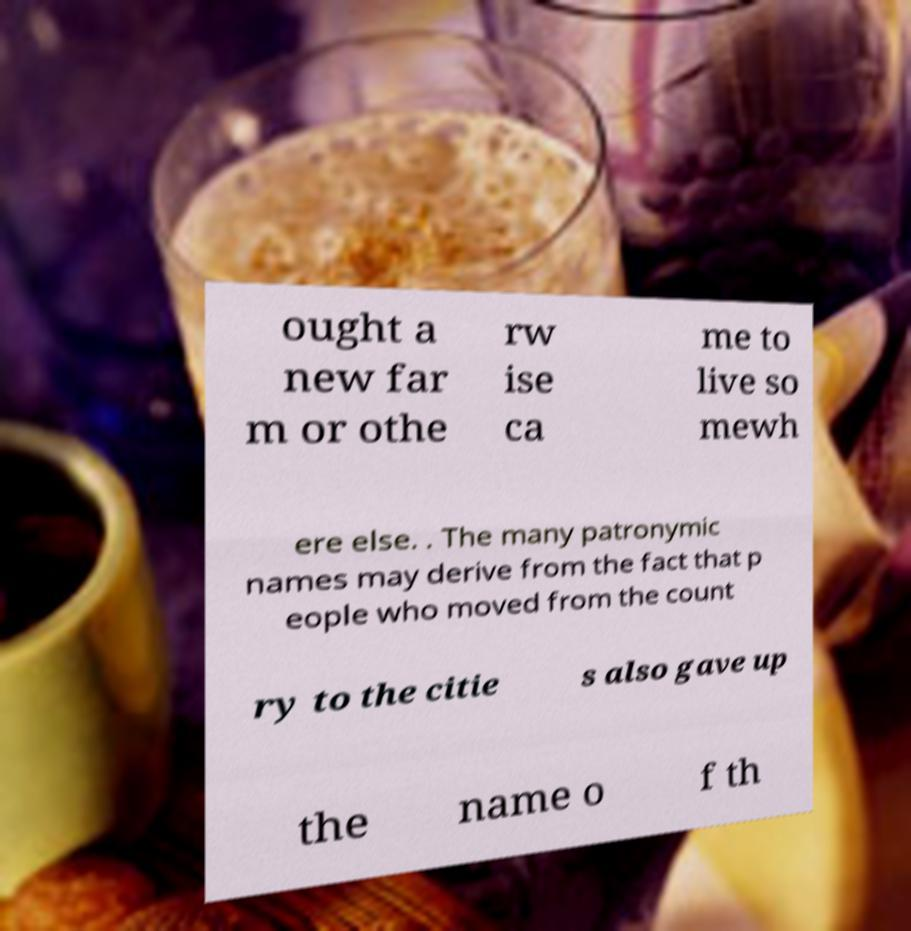Can you accurately transcribe the text from the provided image for me? ought a new far m or othe rw ise ca me to live so mewh ere else. . The many patronymic names may derive from the fact that p eople who moved from the count ry to the citie s also gave up the name o f th 